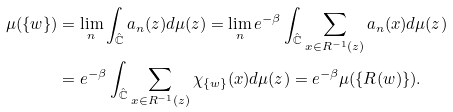Convert formula to latex. <formula><loc_0><loc_0><loc_500><loc_500>\mu ( \{ w \} ) & = \lim _ { n } \int _ { \hat { \mathbb { C } } } a _ { n } ( z ) d \mu ( z ) = \lim _ { n } e ^ { - \beta } \int _ { \hat { \mathbb { C } } } \sum _ { x \in R ^ { - 1 } ( z ) } a _ { n } ( x ) d \mu ( z ) \\ & = e ^ { - \beta } \int _ { \hat { \mathbb { C } } } \sum _ { x \in R ^ { - 1 } ( z ) } \chi _ { \{ w \} } ( x ) d \mu ( z ) = e ^ { - \beta } \mu ( \{ R ( w ) \} ) .</formula> 